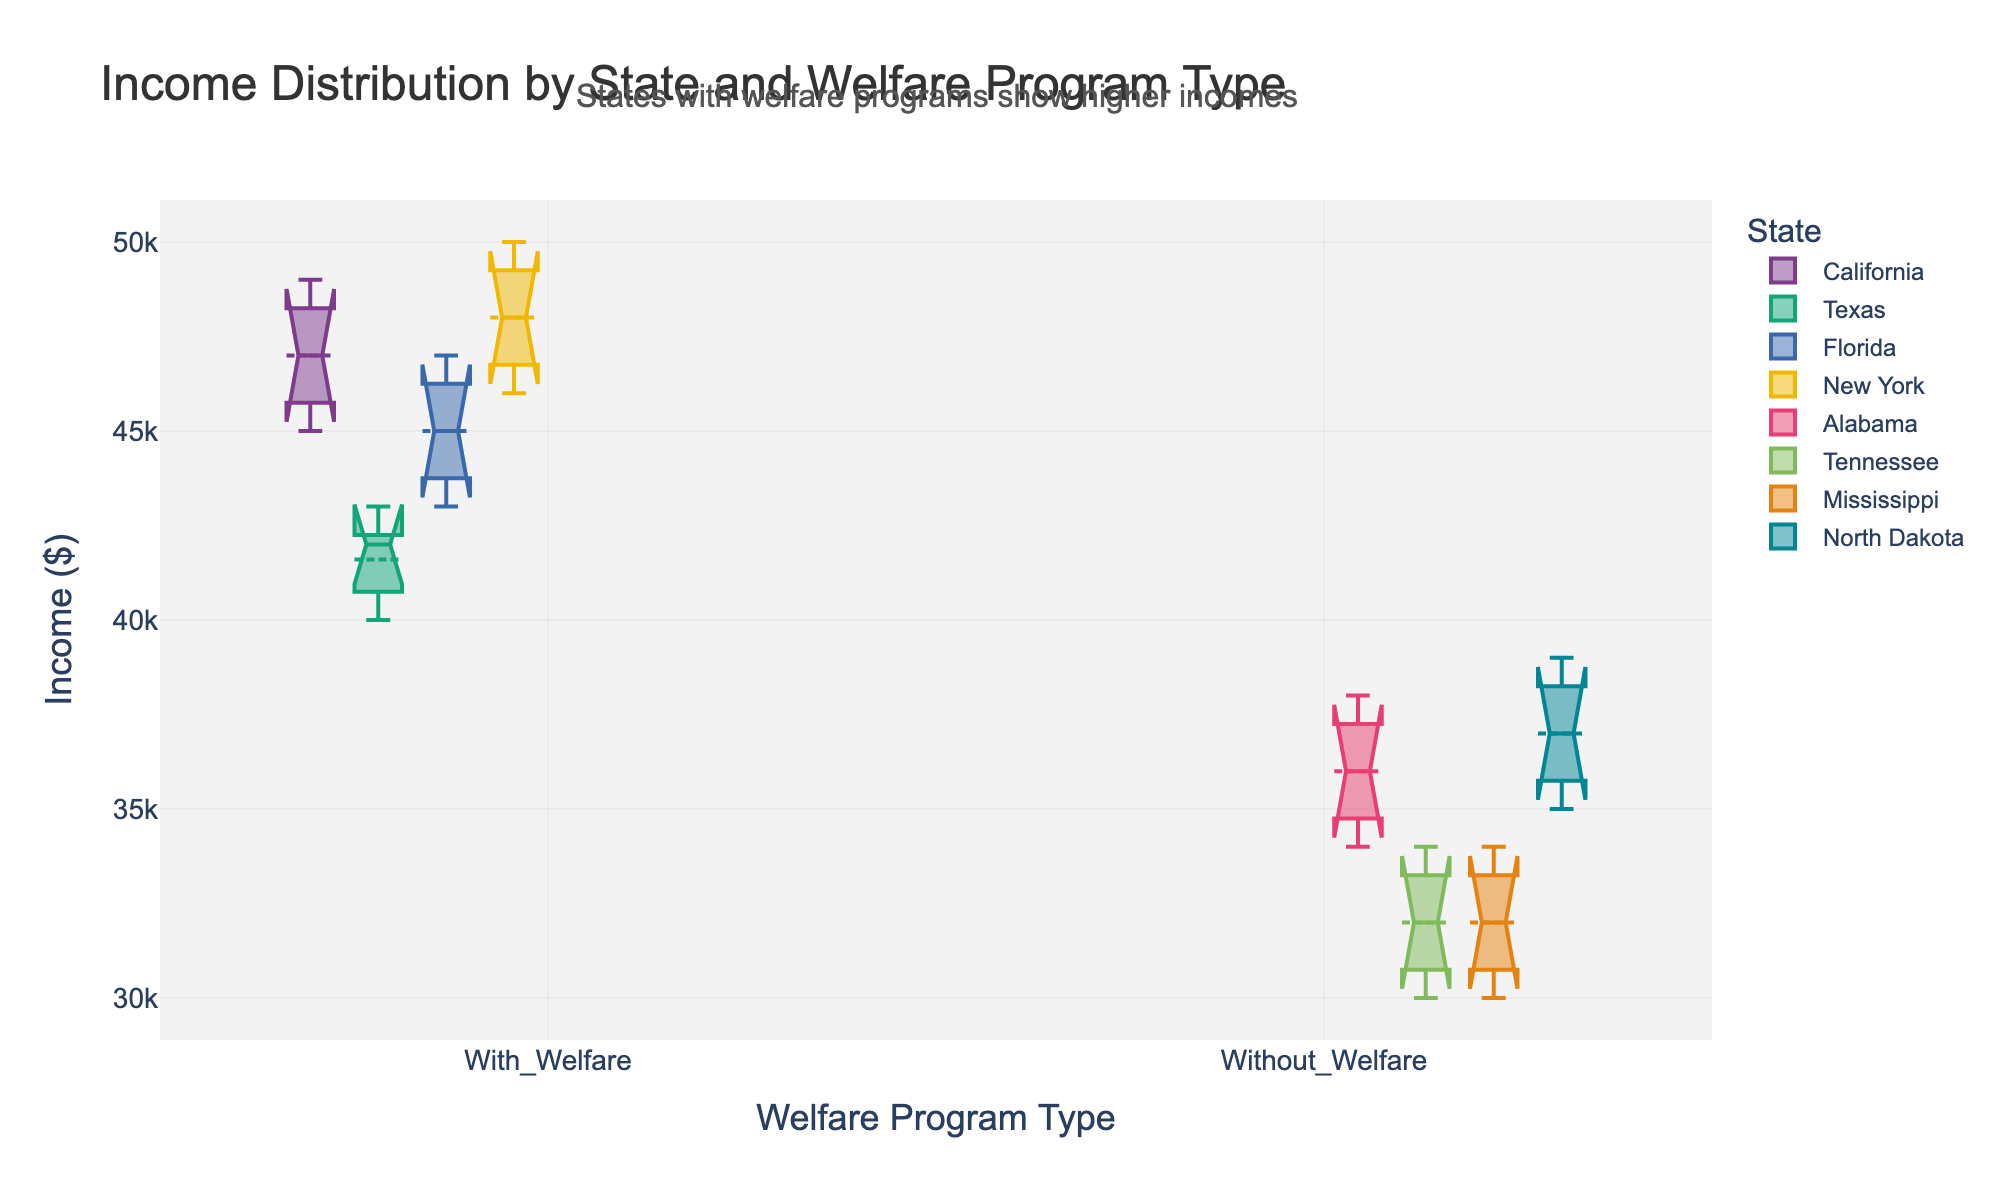What is the title of the figure? The title of the figure is displayed at the top. By reading the text there, we can identify the title.
Answer: Income Distribution by State and Welfare Program Type What are the two categories on the x-axis? The x-axis labels the two categories. By looking at the labels, we can identify the categories.
Answer: With_Welfare, Without_Welfare Which state has the highest income range with welfare programs? By examining the boxplots grouped under "With_Welfare" and comparing their ranges, we observe which state's boxplot extends the most.
Answer: New York What is the median income for Texas with welfare programs? By locating the boxplot representing Texas under "With_Welfare" and observing the central line in that boxplot, we find the median value.
Answer: 42000 Is the income generally higher for states with or without welfare programs? By comparing the overall position and range of the boxplots under "With_Welfare" and "Without_Welfare," we can determine which group has higher incomes.
Answer: With welfare programs What is the interquartile range (IQR) for Florida with welfare programs? For the boxplot of Florida under "With_Welfare," the IQR is the difference between the third quartile (top of the box) and the first quartile (bottom of the box).
Answer: 30,000 (47,000 - 44,000) Which state has the lowest median income without welfare programs? By examining the central lines of the boxplots under "Without_Welfare" and identifying the lowest one, we find the state.
Answer: Mississippi How does the median income of Alabama without welfare compare to California with welfare? Locate the median lines for Alabama under "Without_Welfare" and California under "With_Welfare" and compare their positions on the y-axis.
Answer: Lower Calculate the average median income across all states with welfare programs. Find the median incomes for California, Texas, Florida, and New York under "With_Welfare" and average them: (47000 + 42000 + 45000 + 48000) / 4.
Answer: 45500 Which states exhibit more income variation with welfare programs? By comparing the lengths of the boxplots' whiskers and boxes under "With_Welfare," we identify the states with the widest spread.
Answer: California, New York 